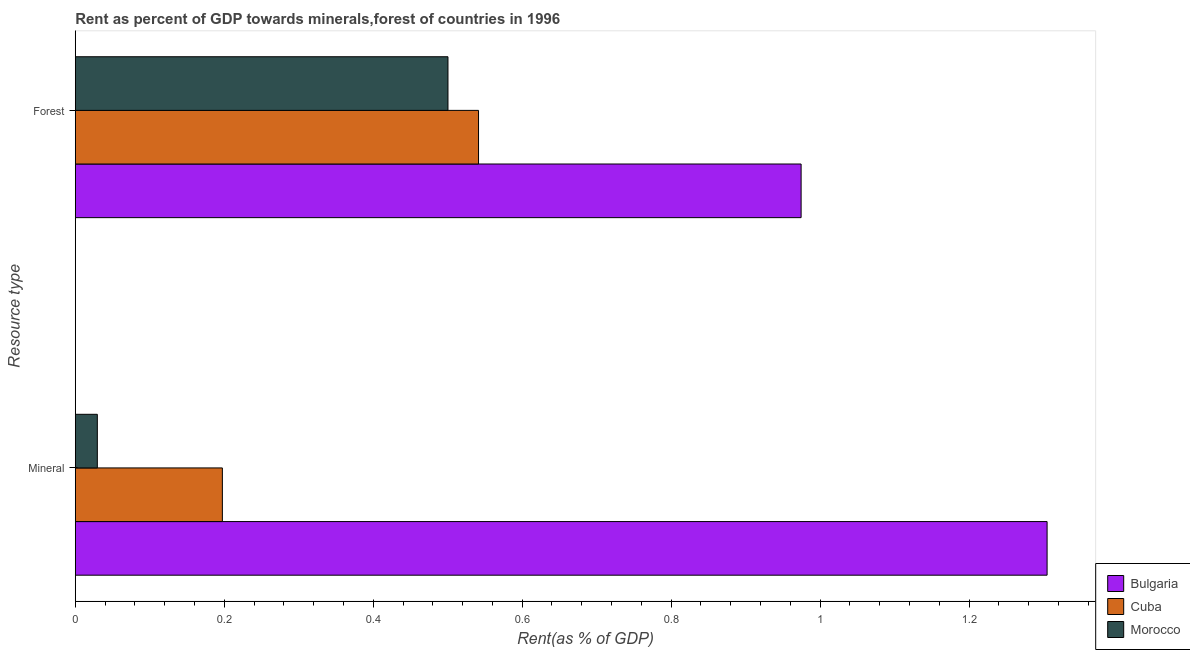How many groups of bars are there?
Your response must be concise. 2. Are the number of bars per tick equal to the number of legend labels?
Offer a terse response. Yes. Are the number of bars on each tick of the Y-axis equal?
Keep it short and to the point. Yes. What is the label of the 1st group of bars from the top?
Offer a very short reply. Forest. What is the mineral rent in Bulgaria?
Ensure brevity in your answer.  1.3. Across all countries, what is the maximum mineral rent?
Provide a succinct answer. 1.3. Across all countries, what is the minimum mineral rent?
Keep it short and to the point. 0.03. In which country was the forest rent maximum?
Your answer should be very brief. Bulgaria. In which country was the mineral rent minimum?
Provide a succinct answer. Morocco. What is the total mineral rent in the graph?
Offer a very short reply. 1.53. What is the difference between the forest rent in Bulgaria and that in Cuba?
Your response must be concise. 0.43. What is the difference between the forest rent in Morocco and the mineral rent in Cuba?
Keep it short and to the point. 0.3. What is the average mineral rent per country?
Your answer should be very brief. 0.51. What is the difference between the mineral rent and forest rent in Bulgaria?
Give a very brief answer. 0.33. What is the ratio of the forest rent in Bulgaria to that in Morocco?
Keep it short and to the point. 1.95. In how many countries, is the forest rent greater than the average forest rent taken over all countries?
Give a very brief answer. 1. What does the 1st bar from the top in Mineral represents?
Keep it short and to the point. Morocco. What does the 2nd bar from the bottom in Mineral represents?
Give a very brief answer. Cuba. How many bars are there?
Offer a very short reply. 6. What is the difference between two consecutive major ticks on the X-axis?
Ensure brevity in your answer.  0.2. Are the values on the major ticks of X-axis written in scientific E-notation?
Ensure brevity in your answer.  No. Does the graph contain any zero values?
Provide a short and direct response. No. What is the title of the graph?
Your answer should be compact. Rent as percent of GDP towards minerals,forest of countries in 1996. What is the label or title of the X-axis?
Make the answer very short. Rent(as % of GDP). What is the label or title of the Y-axis?
Make the answer very short. Resource type. What is the Rent(as % of GDP) of Bulgaria in Mineral?
Offer a very short reply. 1.3. What is the Rent(as % of GDP) in Cuba in Mineral?
Your answer should be compact. 0.2. What is the Rent(as % of GDP) of Morocco in Mineral?
Your response must be concise. 0.03. What is the Rent(as % of GDP) in Bulgaria in Forest?
Your response must be concise. 0.97. What is the Rent(as % of GDP) in Cuba in Forest?
Provide a succinct answer. 0.54. What is the Rent(as % of GDP) of Morocco in Forest?
Offer a very short reply. 0.5. Across all Resource type, what is the maximum Rent(as % of GDP) of Bulgaria?
Make the answer very short. 1.3. Across all Resource type, what is the maximum Rent(as % of GDP) of Cuba?
Give a very brief answer. 0.54. Across all Resource type, what is the maximum Rent(as % of GDP) of Morocco?
Provide a short and direct response. 0.5. Across all Resource type, what is the minimum Rent(as % of GDP) in Bulgaria?
Offer a very short reply. 0.97. Across all Resource type, what is the minimum Rent(as % of GDP) of Cuba?
Your response must be concise. 0.2. Across all Resource type, what is the minimum Rent(as % of GDP) of Morocco?
Your response must be concise. 0.03. What is the total Rent(as % of GDP) in Bulgaria in the graph?
Offer a very short reply. 2.28. What is the total Rent(as % of GDP) in Cuba in the graph?
Ensure brevity in your answer.  0.74. What is the total Rent(as % of GDP) of Morocco in the graph?
Keep it short and to the point. 0.53. What is the difference between the Rent(as % of GDP) of Bulgaria in Mineral and that in Forest?
Your response must be concise. 0.33. What is the difference between the Rent(as % of GDP) of Cuba in Mineral and that in Forest?
Your response must be concise. -0.34. What is the difference between the Rent(as % of GDP) of Morocco in Mineral and that in Forest?
Offer a terse response. -0.47. What is the difference between the Rent(as % of GDP) in Bulgaria in Mineral and the Rent(as % of GDP) in Cuba in Forest?
Your response must be concise. 0.76. What is the difference between the Rent(as % of GDP) of Bulgaria in Mineral and the Rent(as % of GDP) of Morocco in Forest?
Provide a short and direct response. 0.8. What is the difference between the Rent(as % of GDP) in Cuba in Mineral and the Rent(as % of GDP) in Morocco in Forest?
Provide a short and direct response. -0.3. What is the average Rent(as % of GDP) in Bulgaria per Resource type?
Offer a very short reply. 1.14. What is the average Rent(as % of GDP) of Cuba per Resource type?
Your answer should be very brief. 0.37. What is the average Rent(as % of GDP) in Morocco per Resource type?
Make the answer very short. 0.27. What is the difference between the Rent(as % of GDP) in Bulgaria and Rent(as % of GDP) in Cuba in Mineral?
Keep it short and to the point. 1.11. What is the difference between the Rent(as % of GDP) in Bulgaria and Rent(as % of GDP) in Morocco in Mineral?
Give a very brief answer. 1.28. What is the difference between the Rent(as % of GDP) in Cuba and Rent(as % of GDP) in Morocco in Mineral?
Ensure brevity in your answer.  0.17. What is the difference between the Rent(as % of GDP) of Bulgaria and Rent(as % of GDP) of Cuba in Forest?
Ensure brevity in your answer.  0.43. What is the difference between the Rent(as % of GDP) of Bulgaria and Rent(as % of GDP) of Morocco in Forest?
Provide a succinct answer. 0.47. What is the difference between the Rent(as % of GDP) of Cuba and Rent(as % of GDP) of Morocco in Forest?
Provide a short and direct response. 0.04. What is the ratio of the Rent(as % of GDP) in Bulgaria in Mineral to that in Forest?
Give a very brief answer. 1.34. What is the ratio of the Rent(as % of GDP) of Cuba in Mineral to that in Forest?
Your answer should be very brief. 0.36. What is the ratio of the Rent(as % of GDP) in Morocco in Mineral to that in Forest?
Provide a succinct answer. 0.06. What is the difference between the highest and the second highest Rent(as % of GDP) of Bulgaria?
Offer a very short reply. 0.33. What is the difference between the highest and the second highest Rent(as % of GDP) in Cuba?
Your response must be concise. 0.34. What is the difference between the highest and the second highest Rent(as % of GDP) in Morocco?
Your answer should be compact. 0.47. What is the difference between the highest and the lowest Rent(as % of GDP) in Bulgaria?
Make the answer very short. 0.33. What is the difference between the highest and the lowest Rent(as % of GDP) in Cuba?
Offer a very short reply. 0.34. What is the difference between the highest and the lowest Rent(as % of GDP) in Morocco?
Ensure brevity in your answer.  0.47. 